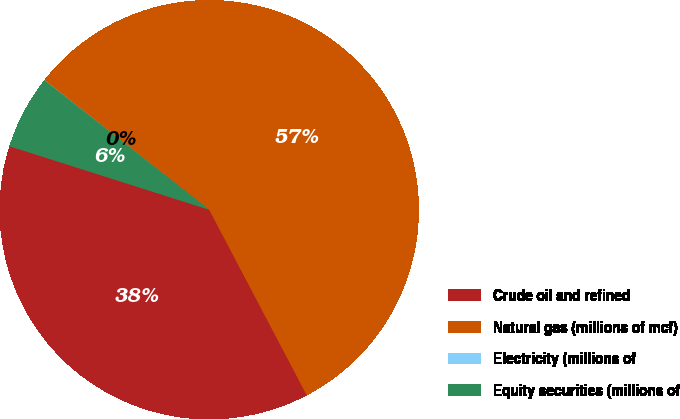Convert chart. <chart><loc_0><loc_0><loc_500><loc_500><pie_chart><fcel>Crude oil and refined<fcel>Natural gas (millions of mcf)<fcel>Electricity (millions of<fcel>Equity securities (millions of<nl><fcel>37.61%<fcel>56.68%<fcel>0.02%<fcel>5.69%<nl></chart> 